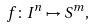<formula> <loc_0><loc_0><loc_500><loc_500>f \colon I ^ { n } \mapsto S ^ { m } ,</formula> 